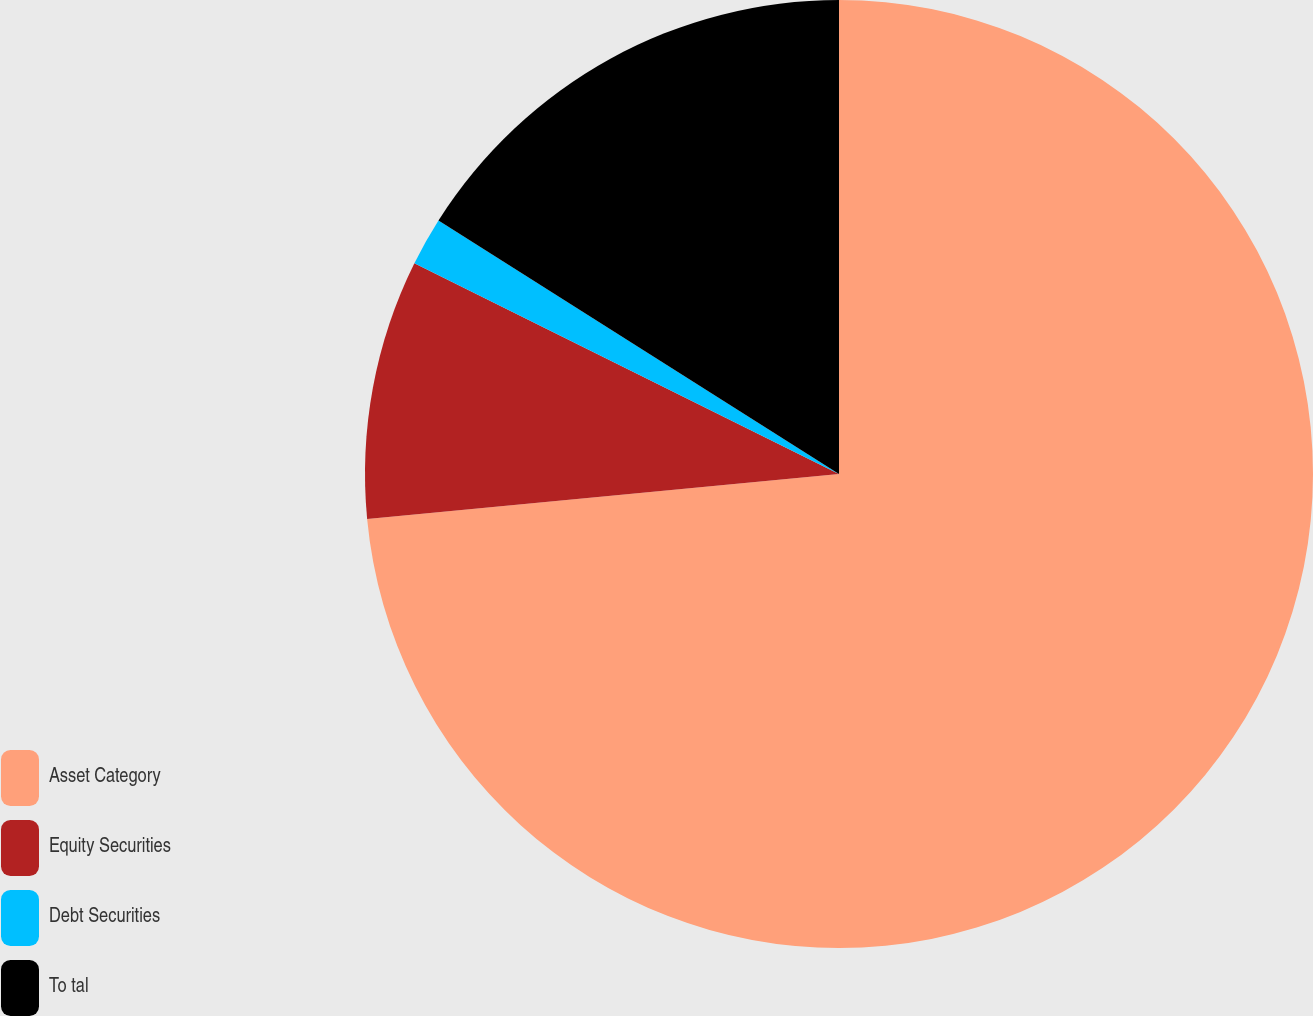<chart> <loc_0><loc_0><loc_500><loc_500><pie_chart><fcel>Asset Category<fcel>Equity Securities<fcel>Debt Securities<fcel>To tal<nl><fcel>73.49%<fcel>8.84%<fcel>1.65%<fcel>16.02%<nl></chart> 